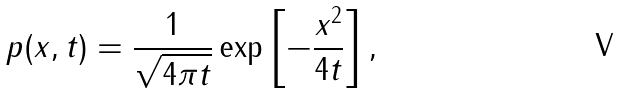<formula> <loc_0><loc_0><loc_500><loc_500>p ( x , t ) = \frac { 1 } { \sqrt { 4 \pi t } } \exp \left [ - \frac { x ^ { 2 } } { 4 t } \right ] ,</formula> 